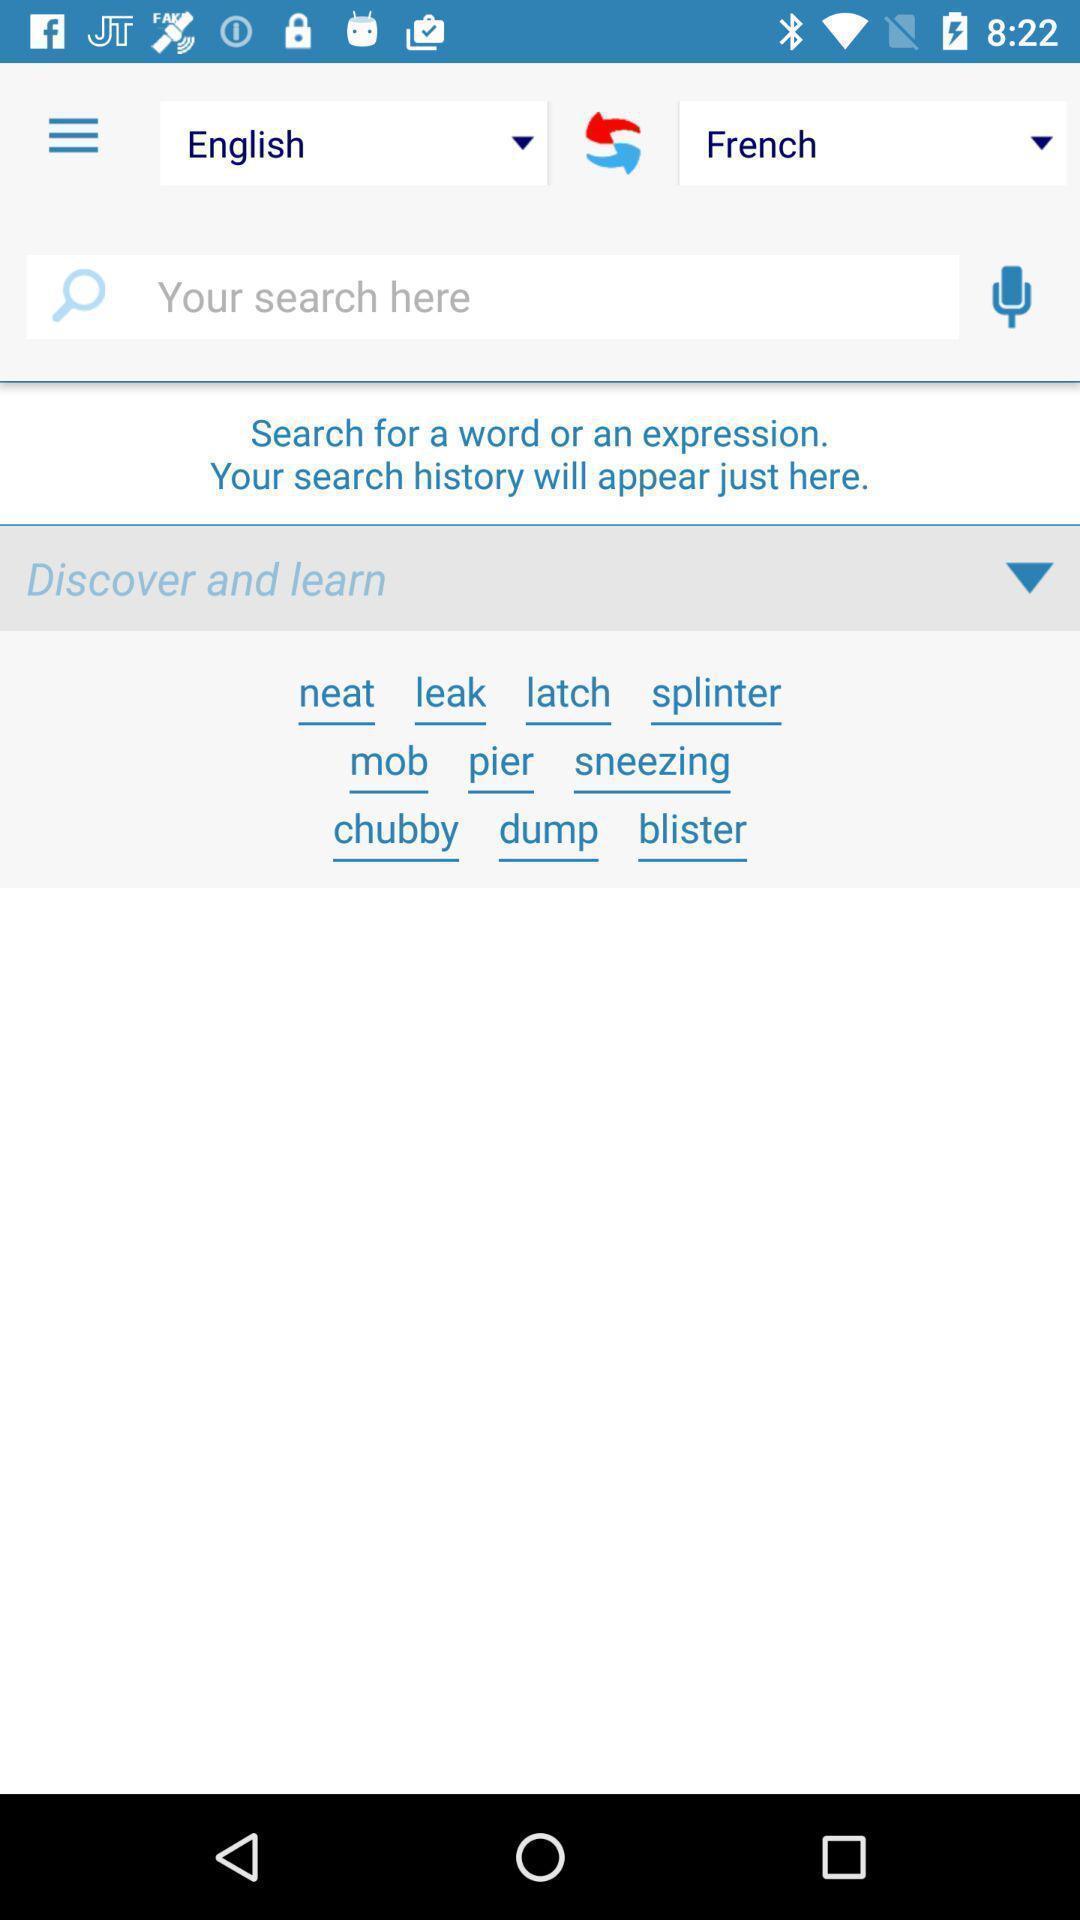Tell me about the visual elements in this screen capture. Search page for the language translation app. 